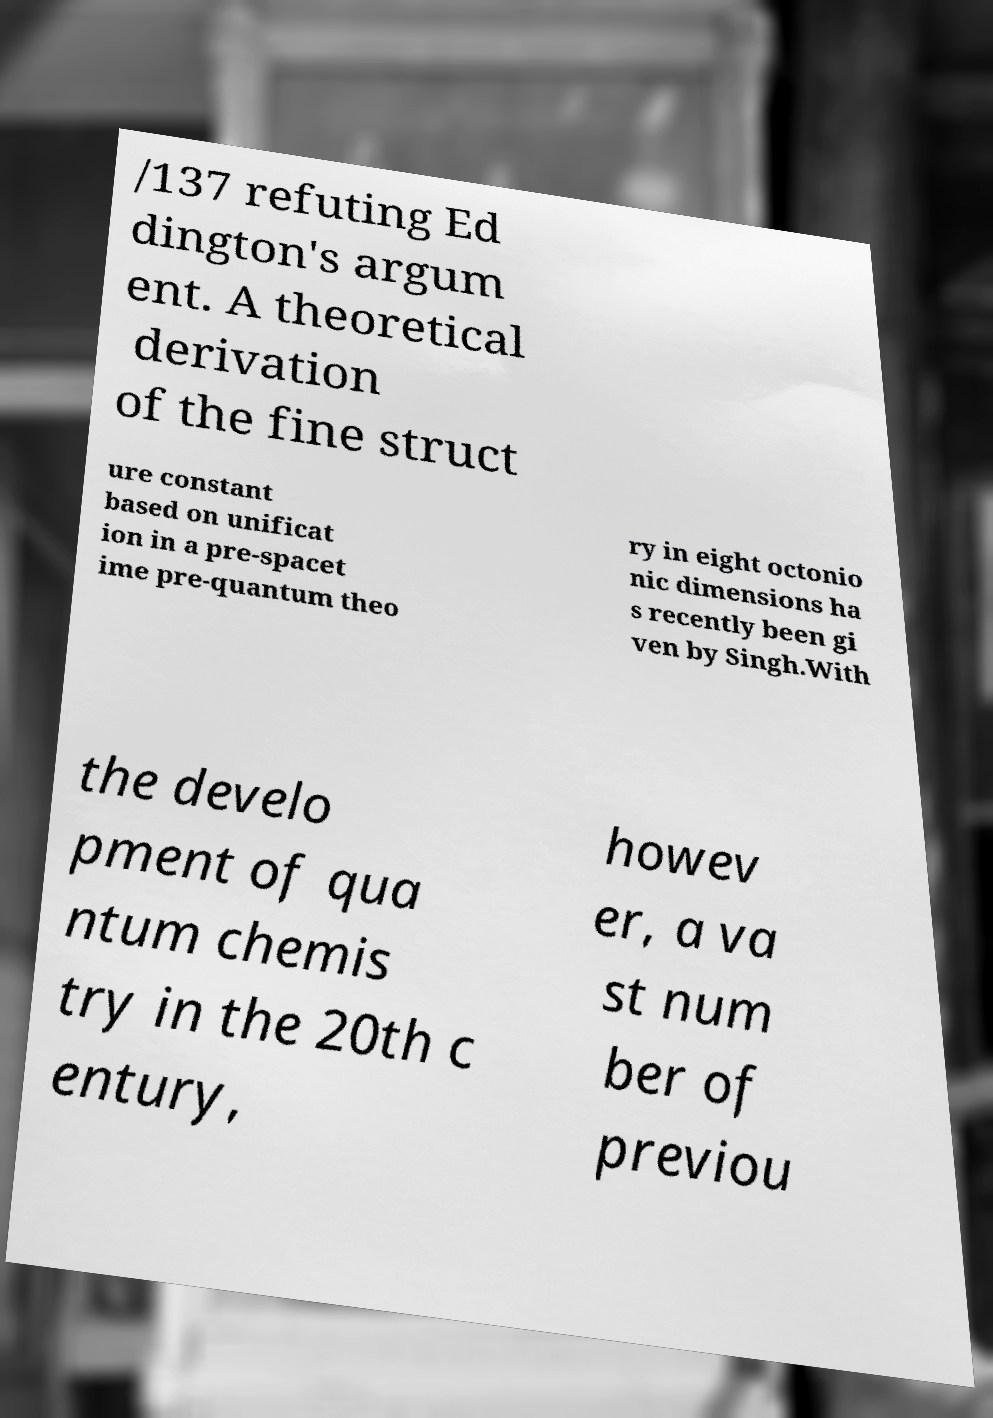Could you extract and type out the text from this image? /137 refuting Ed dington's argum ent. A theoretical derivation of the fine struct ure constant based on unificat ion in a pre-spacet ime pre-quantum theo ry in eight octonio nic dimensions ha s recently been gi ven by Singh.With the develo pment of qua ntum chemis try in the 20th c entury, howev er, a va st num ber of previou 